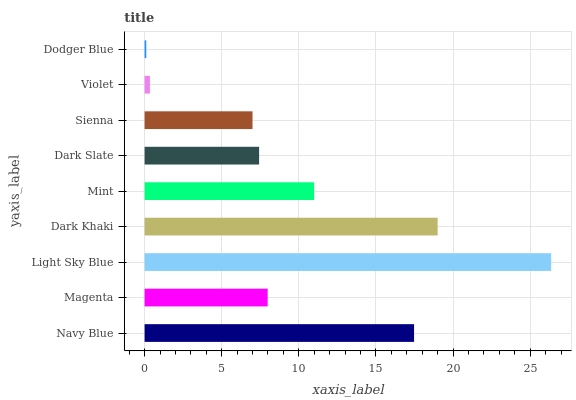Is Dodger Blue the minimum?
Answer yes or no. Yes. Is Light Sky Blue the maximum?
Answer yes or no. Yes. Is Magenta the minimum?
Answer yes or no. No. Is Magenta the maximum?
Answer yes or no. No. Is Navy Blue greater than Magenta?
Answer yes or no. Yes. Is Magenta less than Navy Blue?
Answer yes or no. Yes. Is Magenta greater than Navy Blue?
Answer yes or no. No. Is Navy Blue less than Magenta?
Answer yes or no. No. Is Magenta the high median?
Answer yes or no. Yes. Is Magenta the low median?
Answer yes or no. Yes. Is Sienna the high median?
Answer yes or no. No. Is Dark Khaki the low median?
Answer yes or no. No. 